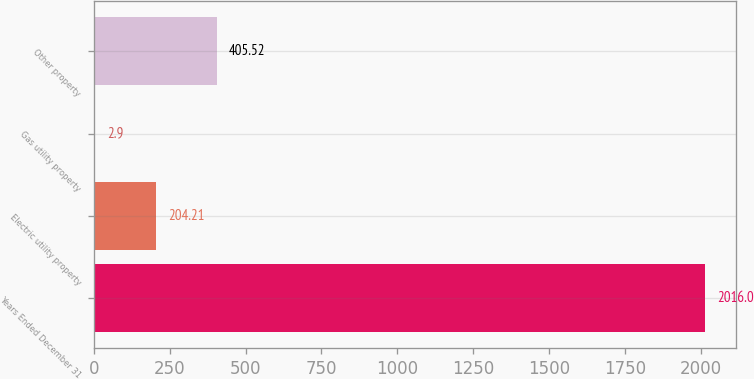Convert chart to OTSL. <chart><loc_0><loc_0><loc_500><loc_500><bar_chart><fcel>Years Ended December 31<fcel>Electric utility property<fcel>Gas utility property<fcel>Other property<nl><fcel>2016<fcel>204.21<fcel>2.9<fcel>405.52<nl></chart> 